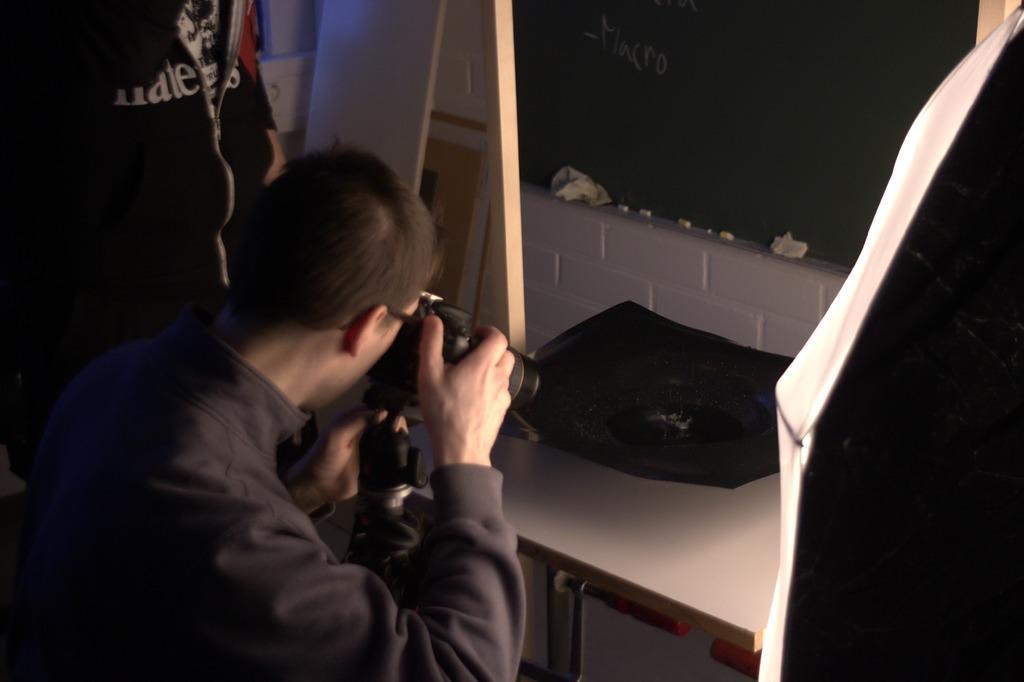Describe this image in one or two sentences. In this picture we can see few people, and a man is taking picture with the help of camera, in front of him we can see an object on the table. 